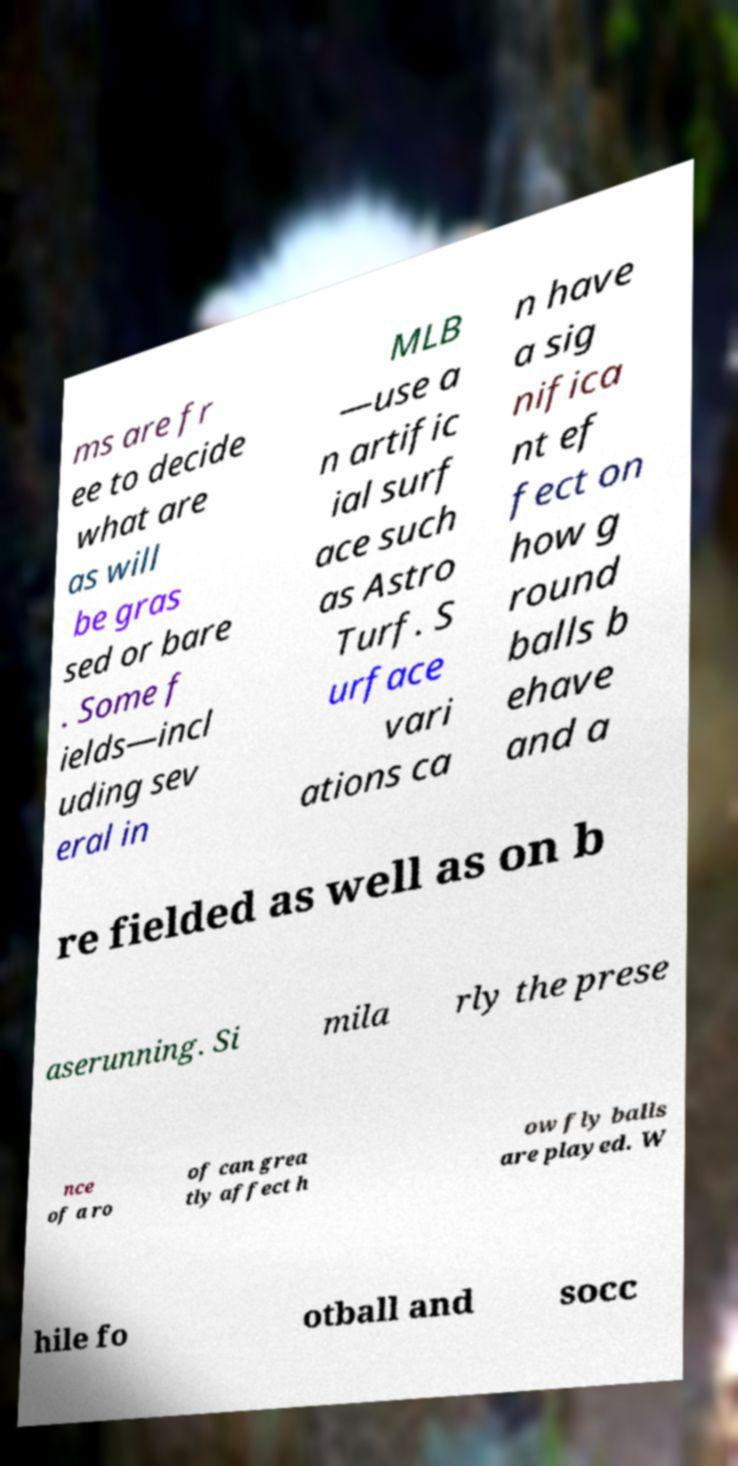What messages or text are displayed in this image? I need them in a readable, typed format. ms are fr ee to decide what are as will be gras sed or bare . Some f ields—incl uding sev eral in MLB —use a n artific ial surf ace such as Astro Turf. S urface vari ations ca n have a sig nifica nt ef fect on how g round balls b ehave and a re fielded as well as on b aserunning. Si mila rly the prese nce of a ro of can grea tly affect h ow fly balls are played. W hile fo otball and socc 